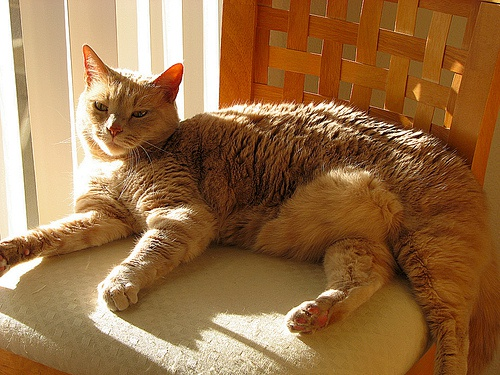Describe the objects in this image and their specific colors. I can see cat in white, maroon, brown, and black tones and chair in white, brown, olive, and maroon tones in this image. 